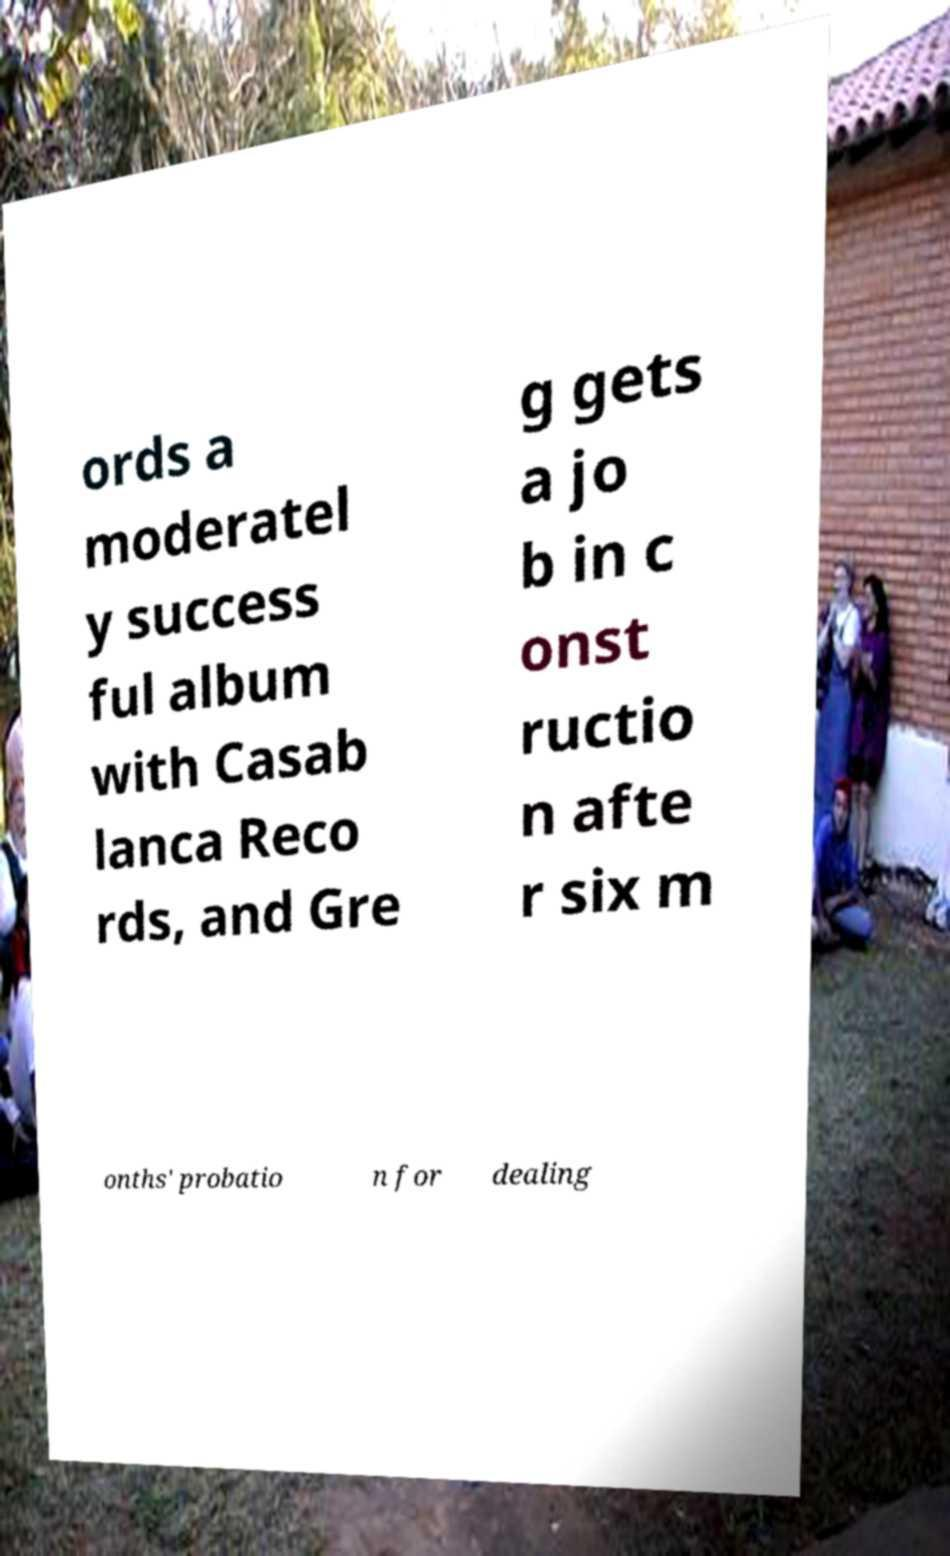Can you read and provide the text displayed in the image?This photo seems to have some interesting text. Can you extract and type it out for me? ords a moderatel y success ful album with Casab lanca Reco rds, and Gre g gets a jo b in c onst ructio n afte r six m onths' probatio n for dealing 